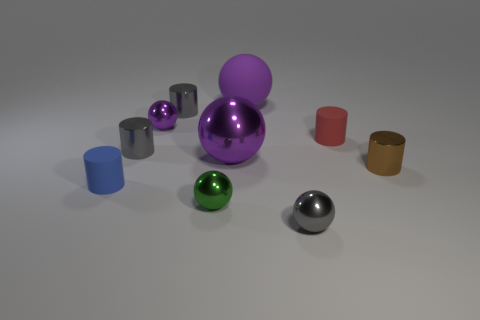There is a gray metallic thing on the right side of the tiny green shiny thing; is it the same shape as the tiny green metallic thing in front of the brown object?
Ensure brevity in your answer.  Yes. There is a brown thing that is the same size as the blue thing; what material is it?
Your answer should be compact. Metal. How many other things are there of the same material as the green object?
Provide a short and direct response. 6. There is a small matte object on the right side of the purple metal thing that is behind the red thing; what is its shape?
Keep it short and to the point. Cylinder. What number of things are either large red rubber cylinders or gray things that are in front of the small red matte cylinder?
Offer a terse response. 2. What number of other objects are there of the same color as the big rubber object?
Offer a very short reply. 2. What number of green objects are either tiny objects or large metallic objects?
Your response must be concise. 1. Are there any metallic objects that are behind the rubber object that is in front of the small rubber object that is behind the brown metal thing?
Ensure brevity in your answer.  Yes. Are there any other things that are the same size as the red rubber object?
Give a very brief answer. Yes. Is the color of the large metallic object the same as the matte ball?
Provide a succinct answer. Yes. 